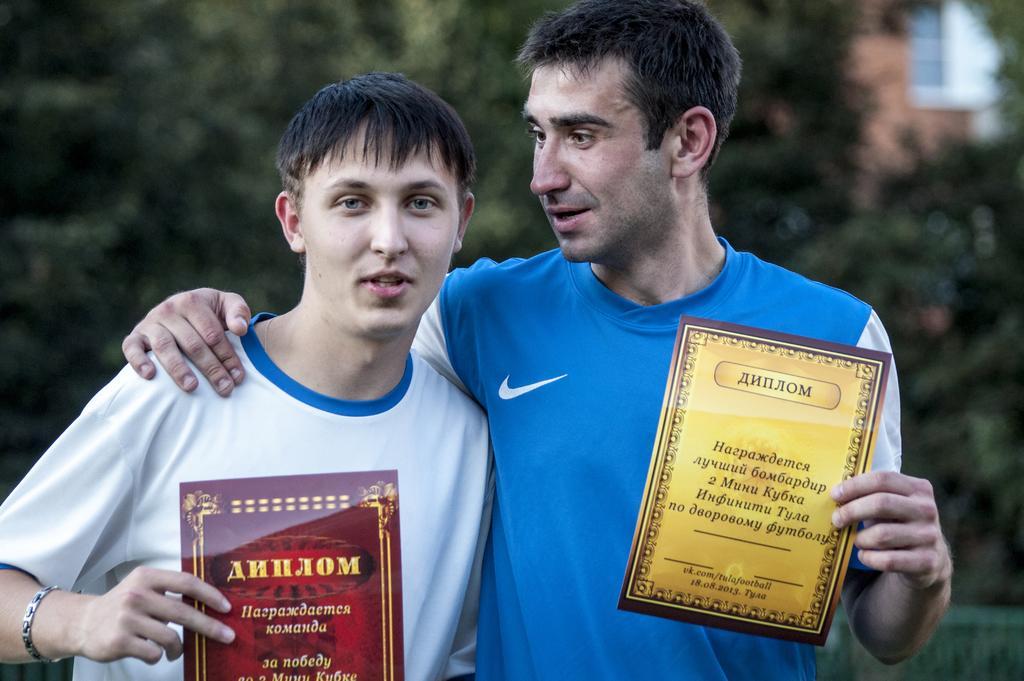How would you summarize this image in a sentence or two? In the foreground I can see two persons are holding certificates in hand. In the background I can see trees and a building wall. This image is taken during a day. 